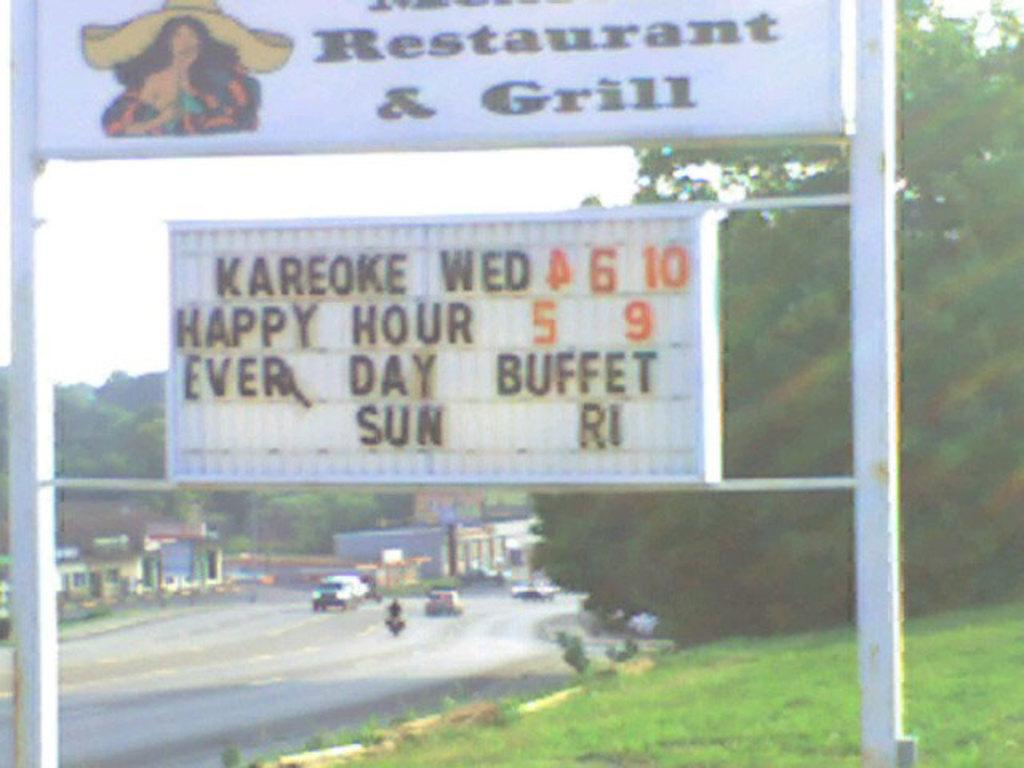Provide a one-sentence caption for the provided image. Restaurant and grill that includes a karoke and every day buffet. 